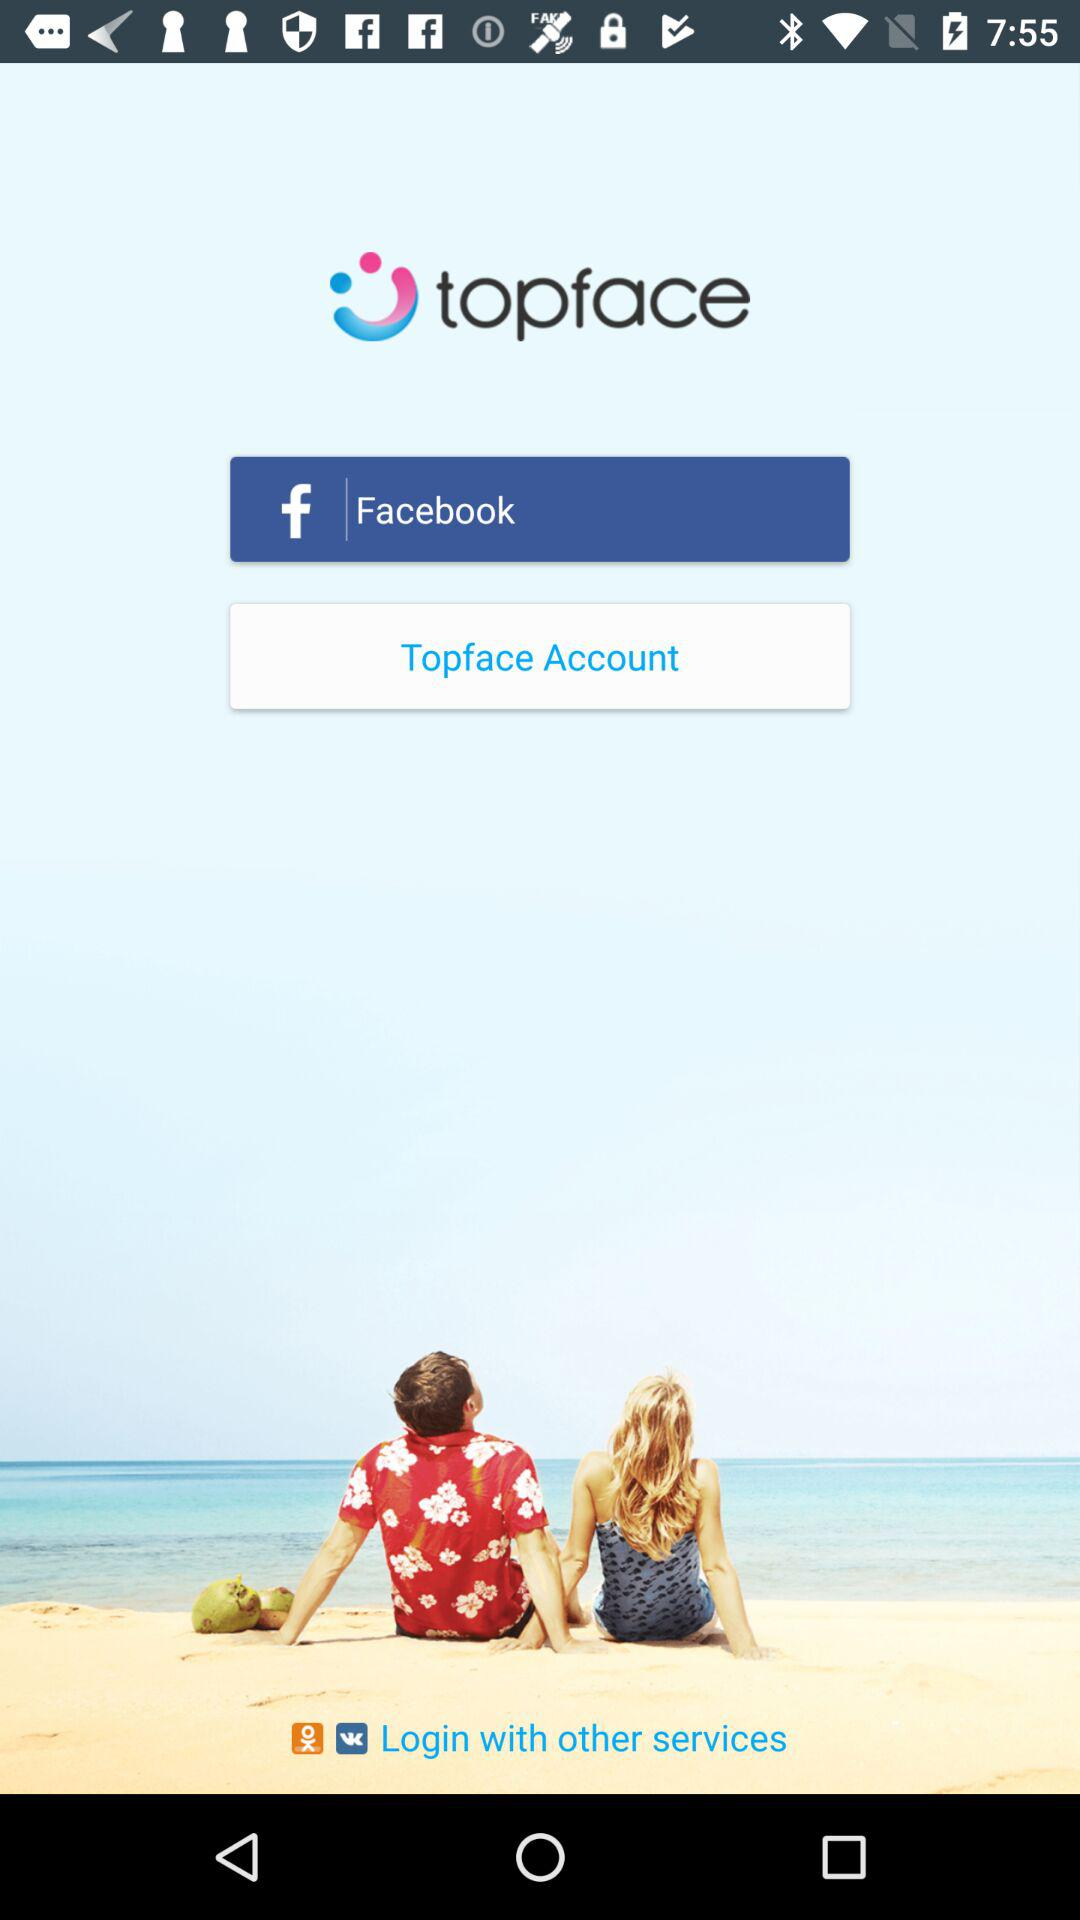Who developed the "topface" app?
When the provided information is insufficient, respond with <no answer>. <no answer> 